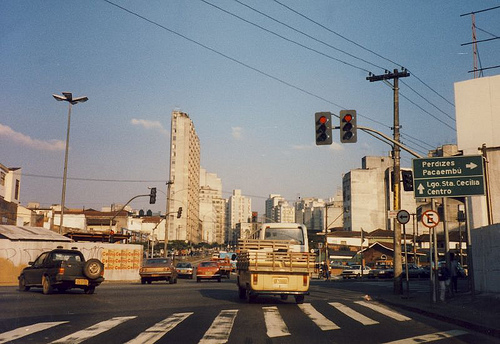Please transcribe the text information in this image. Perdizes Pacaembu Centro Lgo Sta Cecilia 